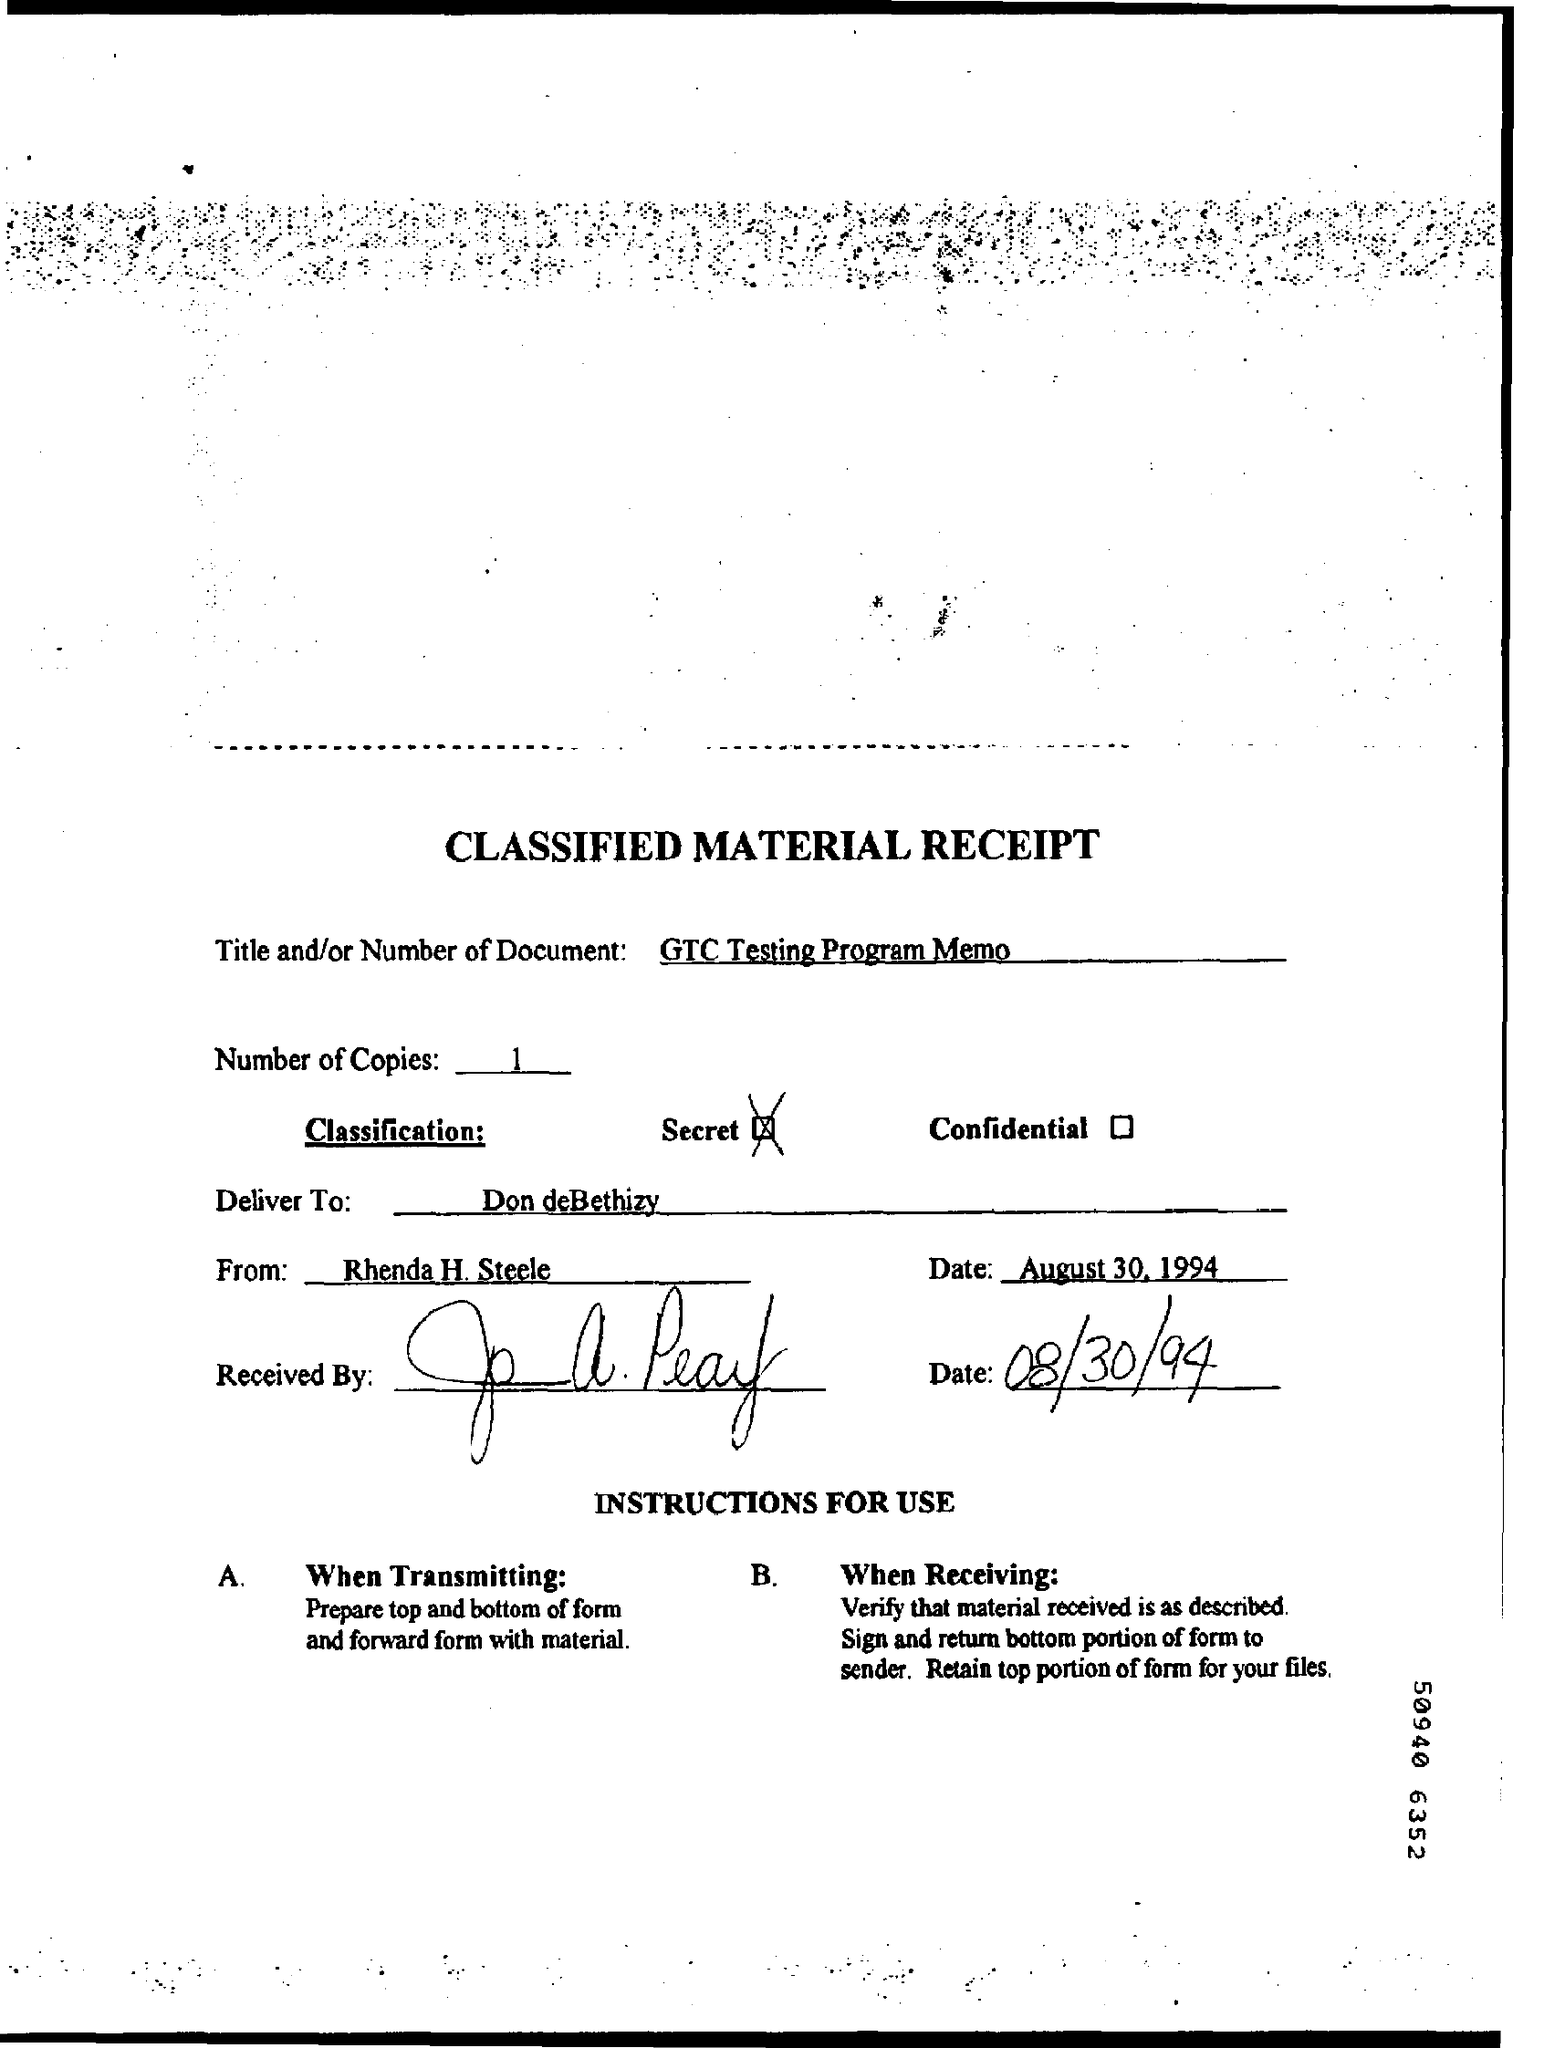How many number of copies ?
Offer a very short reply. 1. What is the classification ?
Provide a short and direct response. Secret. 